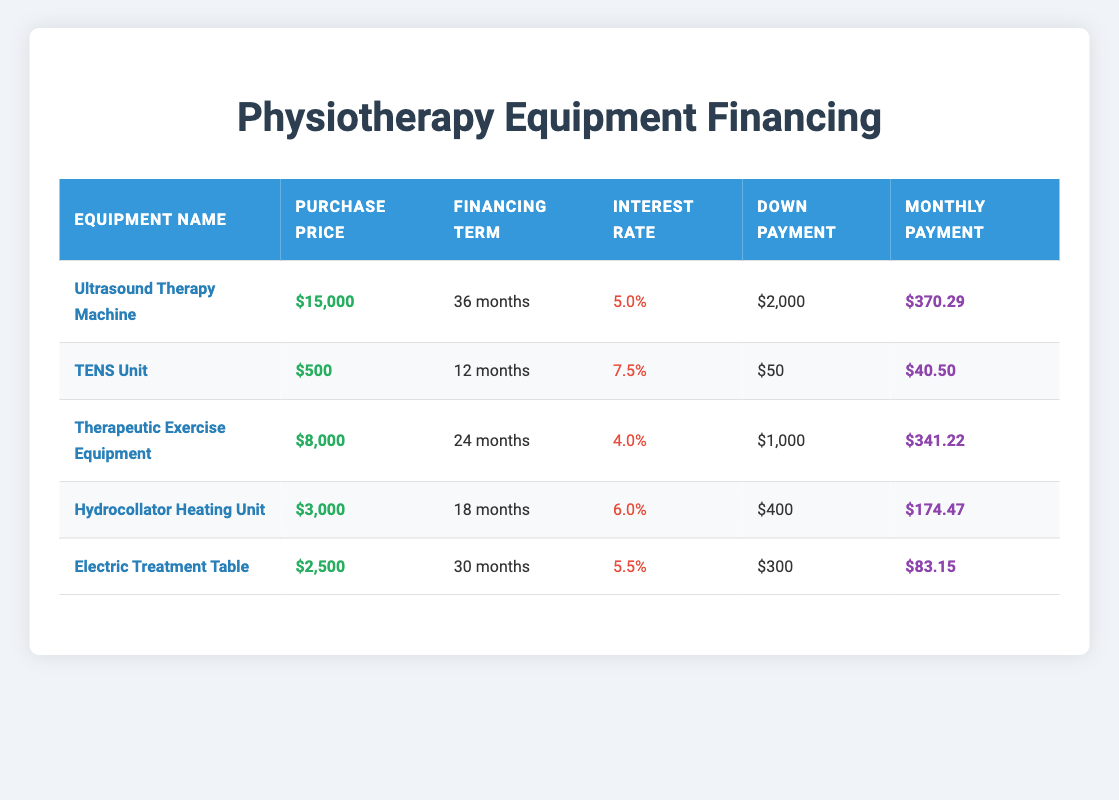What is the monthly payment for the Ultrasound Therapy Machine? The table lists the monthly payment specifically for the Ultrasound Therapy Machine as $370.29 in the corresponding row.
Answer: $370.29 How much is the down payment required for the TENS Unit? The down payment is clearly indicated in the table as $50 for the TENS Unit in its respective row.
Answer: $50 Which equipment has the highest purchase price? By examining the purchase price column, the Ultrasound Therapy Machine has the highest purchase price at $15,000, as all other prices are lower.
Answer: $15,000 How much more is the monthly payment for the Therapeutic Exercise Equipment compared to the Electric Treatment Table? First, identify the monthly payments: Therapeutic Exercise Equipment has $341.22 and the Electric Treatment Table has $83.15. Then, calculate the difference: $341.22 - $83.15 = $258.07.
Answer: $258.07 Is the interest rate for the Hydrocollator Heating Unit higher than 5%? The Hydrocollator Heating Unit has an interest rate specified as 6.0%, which is indeed higher than 5%. Therefore, the answer is yes.
Answer: Yes What is the average financing term for the equipment listed in the table? To find the average, sum the financing terms in months (36 + 12 + 24 + 18 + 30 = 120 months) and divide by the number of items (5): 120 / 5 = 24 months average financing term.
Answer: 24 months Which equipment has the lowest interest rate, and what is it? Looking at the interest rate column, the Therapeutic Exercise Equipment has the lowest interest rate at 4.0%, as all other rates are higher than this.
Answer: 4.0% If I make all the monthly payments for the Hydrocollator Heating Unit, what will the total cost be including the down payment? The monthly payment for the Hydrocollator Heating Unit is $174.47, and the financing term is 18 months. Total monthly payments equal 18 * $174.47 = $3,136.46. Adding the down payment of $400 gives: $3,136.46 + $400 = $3,536.46 total cost.
Answer: $3,536.46 